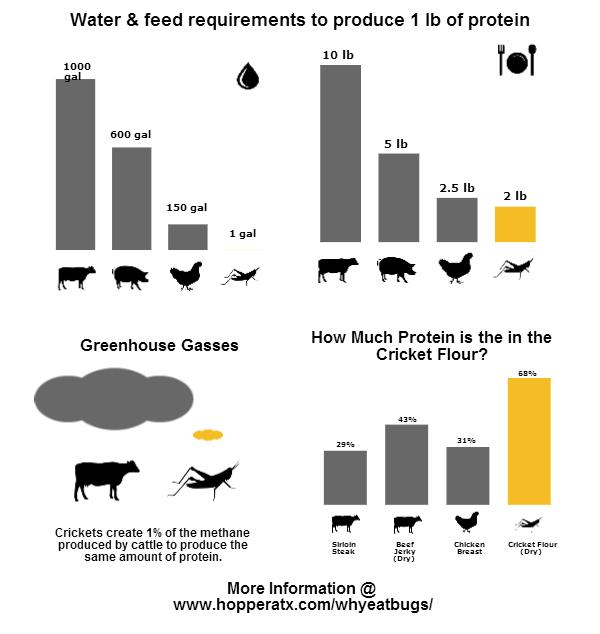Specify some key components in this picture. This 2 lb. package of cricket flour contains an impressive amount of protein. This chicken contains approximately 2.5 pounds of protein. 